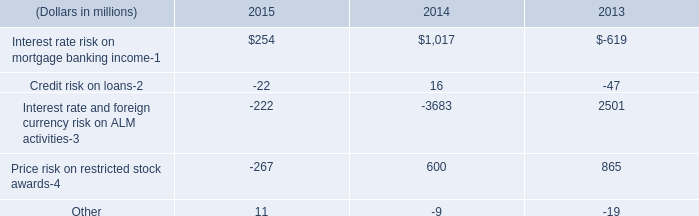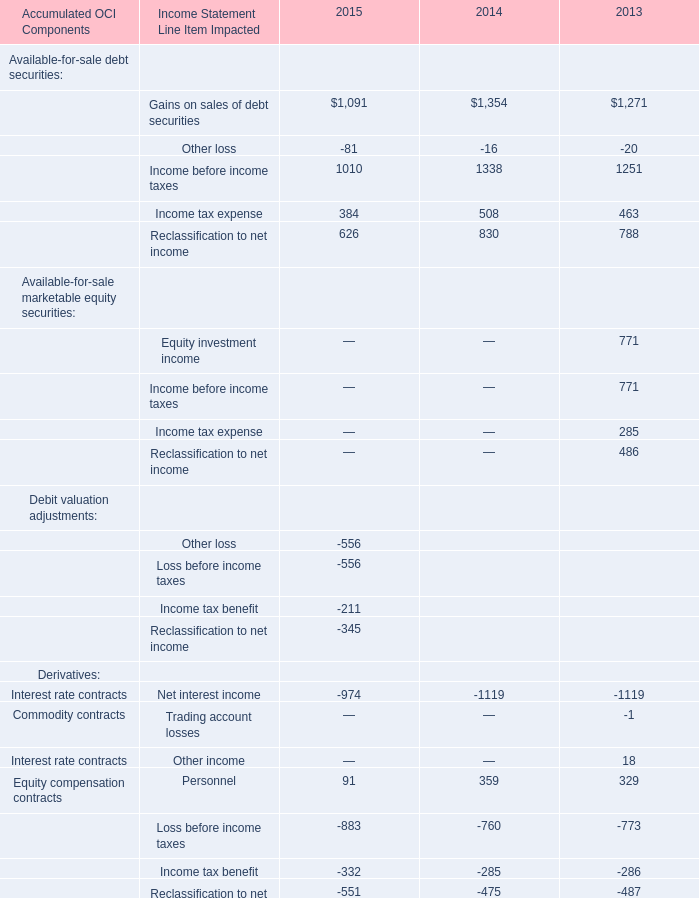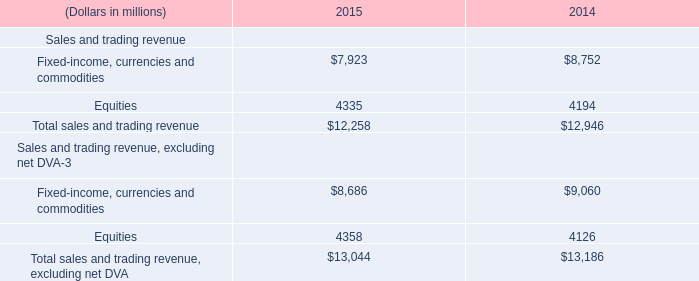what was the percentage increase the contingent rent expense from 2010 to 2011 
Computations: ((3.6 - 2.0) / 2.0)
Answer: 0.8. 